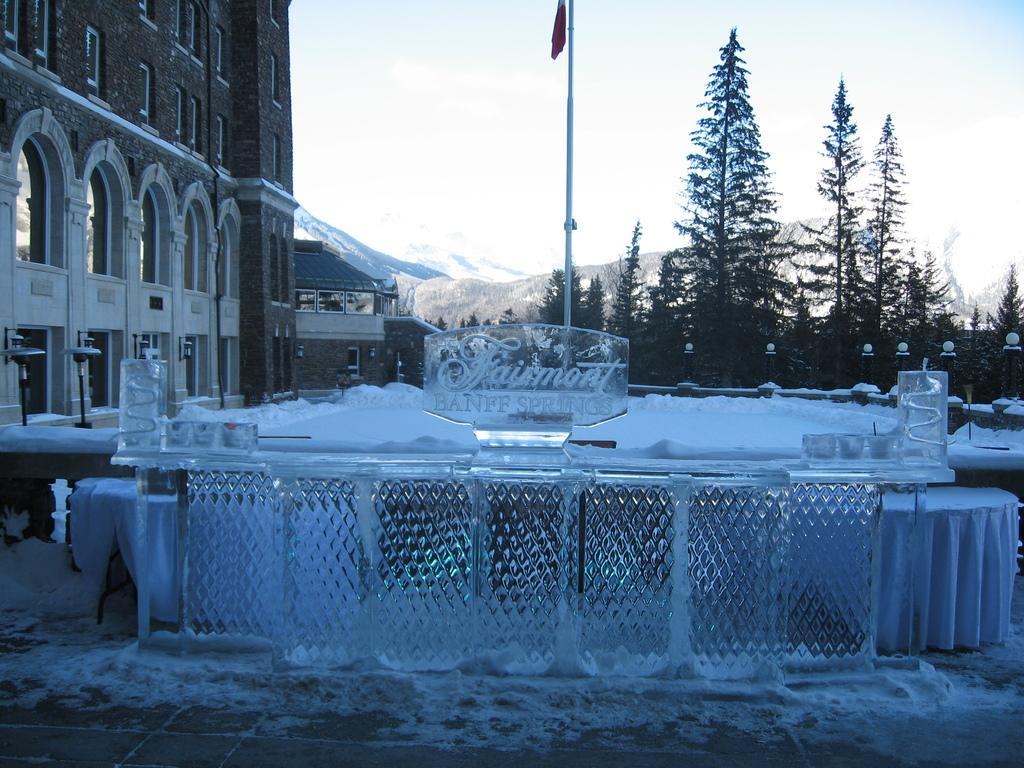What type of structures are visible in the image? There are buildings with windows in the image. What other natural elements can be seen in the image? There are trees in the image. What object is present in the image that might be used for support or signage? There is a pole in the image. What can be seen in the distance in the image? There are mountains in the background of the image. What is visible in the sky in the image? The sky is visible in the background of the image. What type of locket is hanging from the tree in the image? There is no locket present in the image; it features buildings, trees, a pole, mountains, and the sky. 